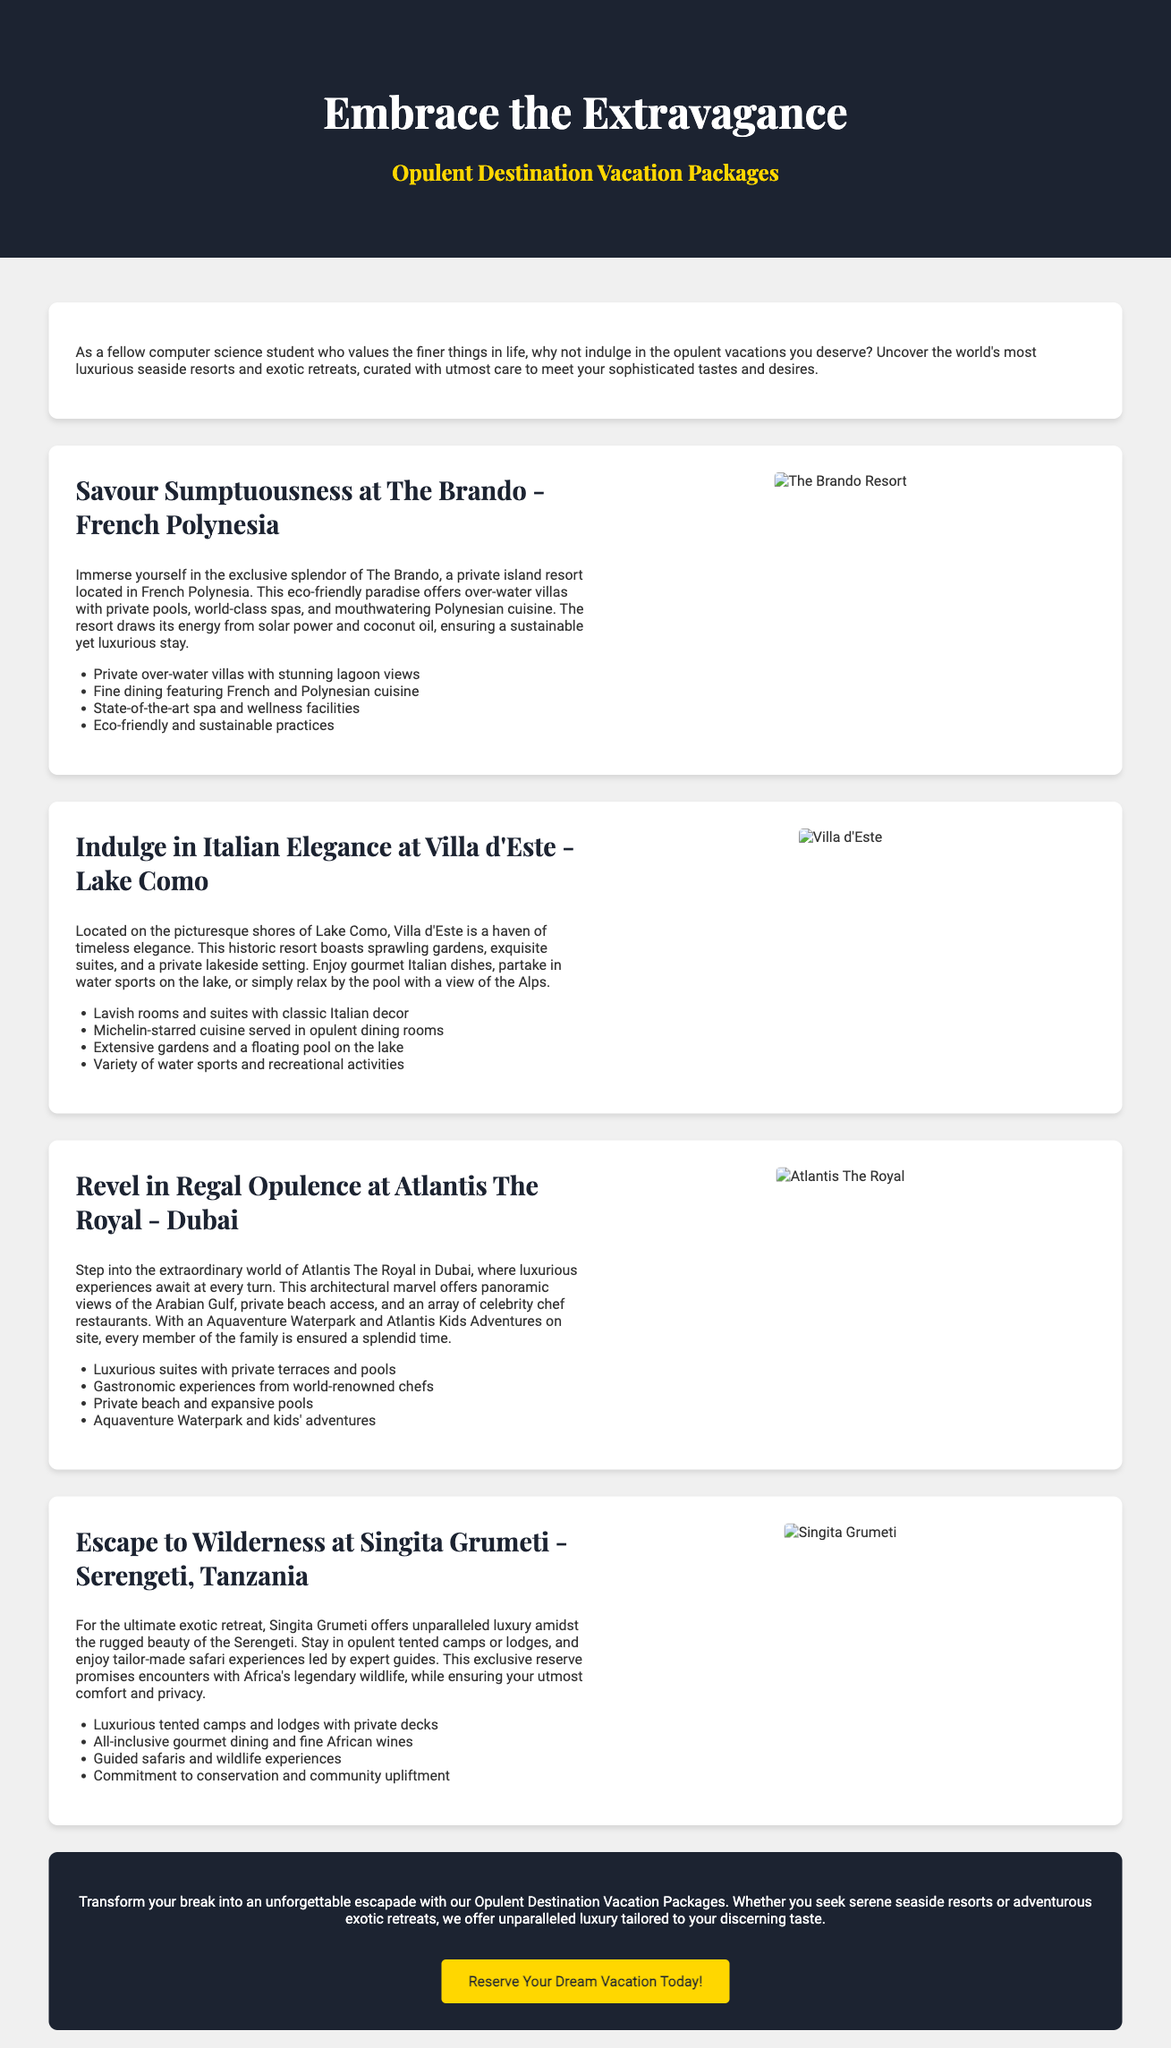What is the title of the advertisement? The title of the advertisement is prominently displayed at the top and indicates the theme of opulence in vacation packages.
Answer: Embrace the Extravagance How many destinations are mentioned in the advertisement? The advertisement showcases four distinct luxury destinations, summarizing their unique offerings.
Answer: Four What is the name of the resort located in French Polynesia? The advertisement includes a specific resort name that aligns with the theme of luxury and exclusivity in a tropical setting.
Answer: The Brando What type of cuisine is served at Villa d'Este? The advertisement highlights the gourmet offerings available at this specific Italian resort, focusing on its high-quality dining experience.
Answer: Michelin-starred cuisine What feature is unique to Singita Grumeti? The advertisement describes this destination as offering an exotic experience with a specific focus on wildlife encounters and tailored experiences.
Answer: Guided safaris What is the call to action in the advertisement? The advertisement concludes with a clear invitation for viewers to take the next step towards booking their luxury experience, suggested by a highlighted button.
Answer: Reserve Your Dream Vacation Today! What is the architectural feature of Atlantis The Royal? The advertisement emphasizes an impressive aspect of this Dubai resort that reflects its grandeur and luxury.
Answer: Architectural marvel What recreational activity is available at Atlantis The Royal? The advertisement mentions a specific activity that caters to both children and adults, showcasing family-friendly options in a luxury setting.
Answer: Aquaventure Waterpark 